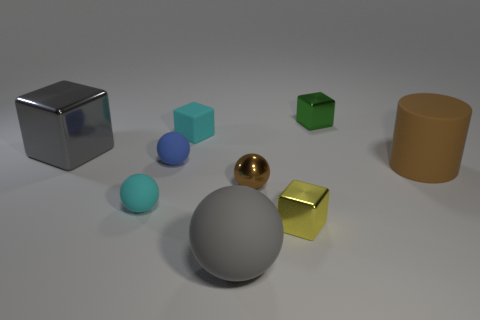Are there the same number of small metal things behind the small green cube and brown metal balls that are on the right side of the big ball?
Your answer should be very brief. No. What color is the thing that is both in front of the large cylinder and on the left side of the blue matte ball?
Your answer should be very brief. Cyan. Are there any other things that have the same size as the yellow metallic block?
Your response must be concise. Yes. Is the number of big brown matte objects left of the blue object greater than the number of large objects behind the large brown object?
Provide a short and direct response. No. Does the gray thing in front of the yellow cube have the same size as the small blue sphere?
Make the answer very short. No. How many cubes are on the left side of the ball in front of the tiny matte object that is in front of the cylinder?
Your answer should be compact. 2. There is a shiny thing that is to the right of the gray metallic thing and behind the metal sphere; how big is it?
Provide a succinct answer. Small. How many other things are the same shape as the tiny green thing?
Make the answer very short. 3. How many green things are in front of the tiny cyan matte cube?
Ensure brevity in your answer.  0. Is the number of gray balls on the right side of the yellow cube less than the number of tiny cyan rubber things that are to the left of the gray metal cube?
Provide a succinct answer. No. 